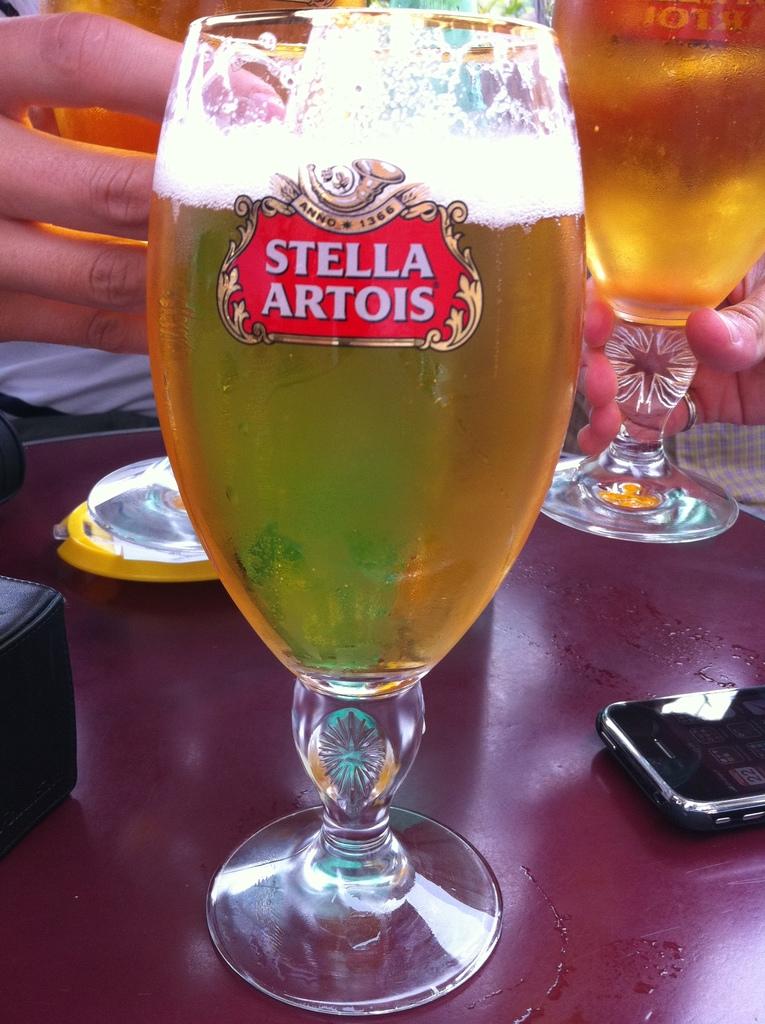What brand of beer is picture on the glass?
Provide a succinct answer. Stella artois. 